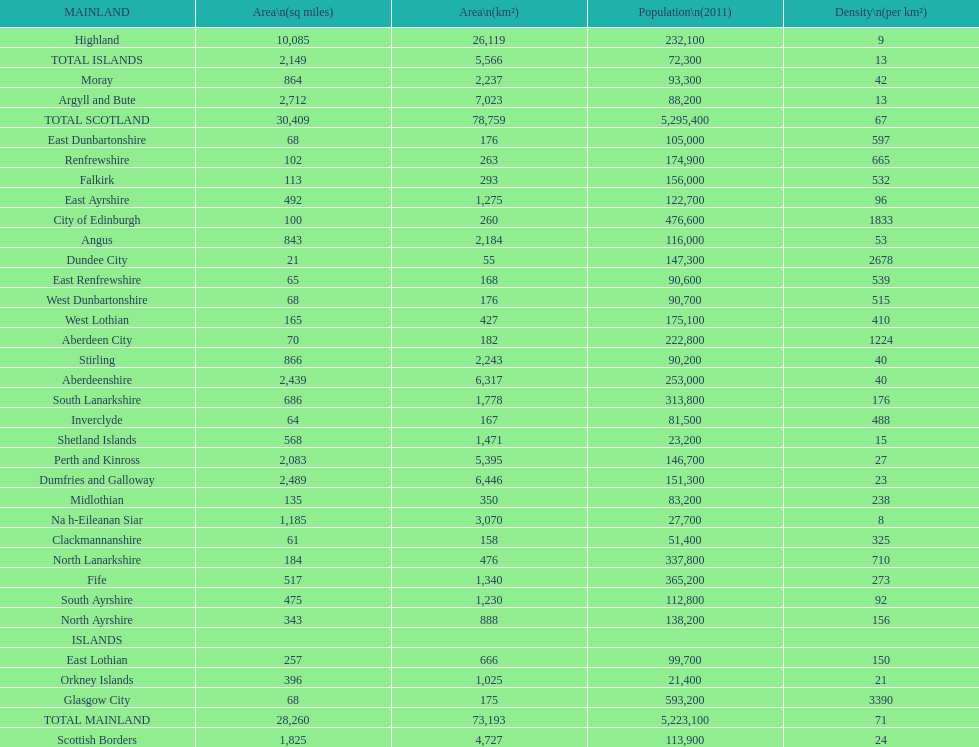What is the total area of east lothian, angus, and dundee city? 1121. 